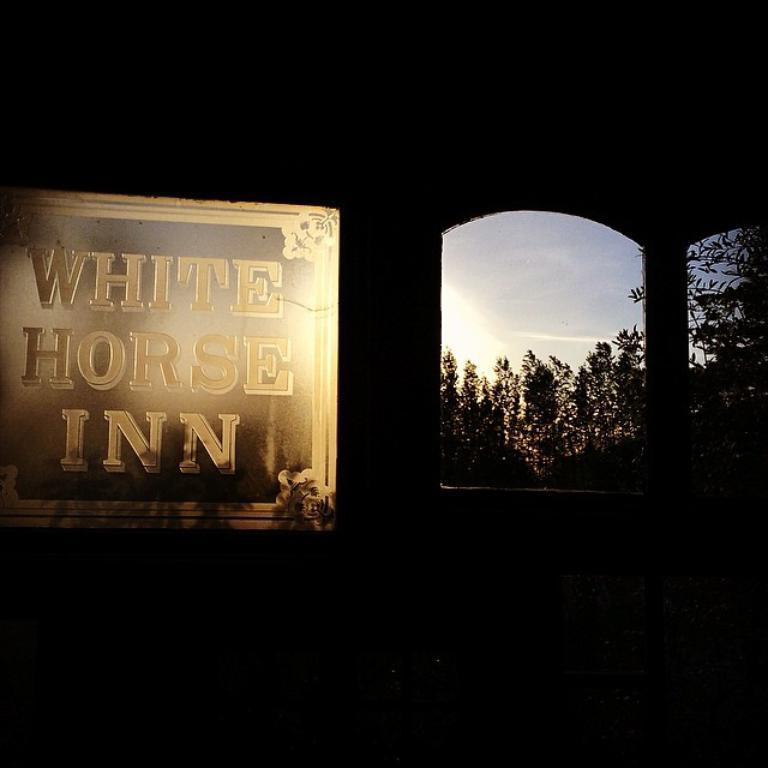What type of vegetation can be seen in the image? There are trees in the image. What is written or displayed on the board in the image? There is a board with text in the image. What can be seen in the sky in the image? The sky is visible in the image. How would you describe the overall lighting or brightness of the image? The background of the image is dark. How many apples are hanging from the trees in the image? There is no mention of apples in the image; it only features trees. Can you see any fingers in the image? There is no mention of fingers in the image; it does not depict any body parts. 